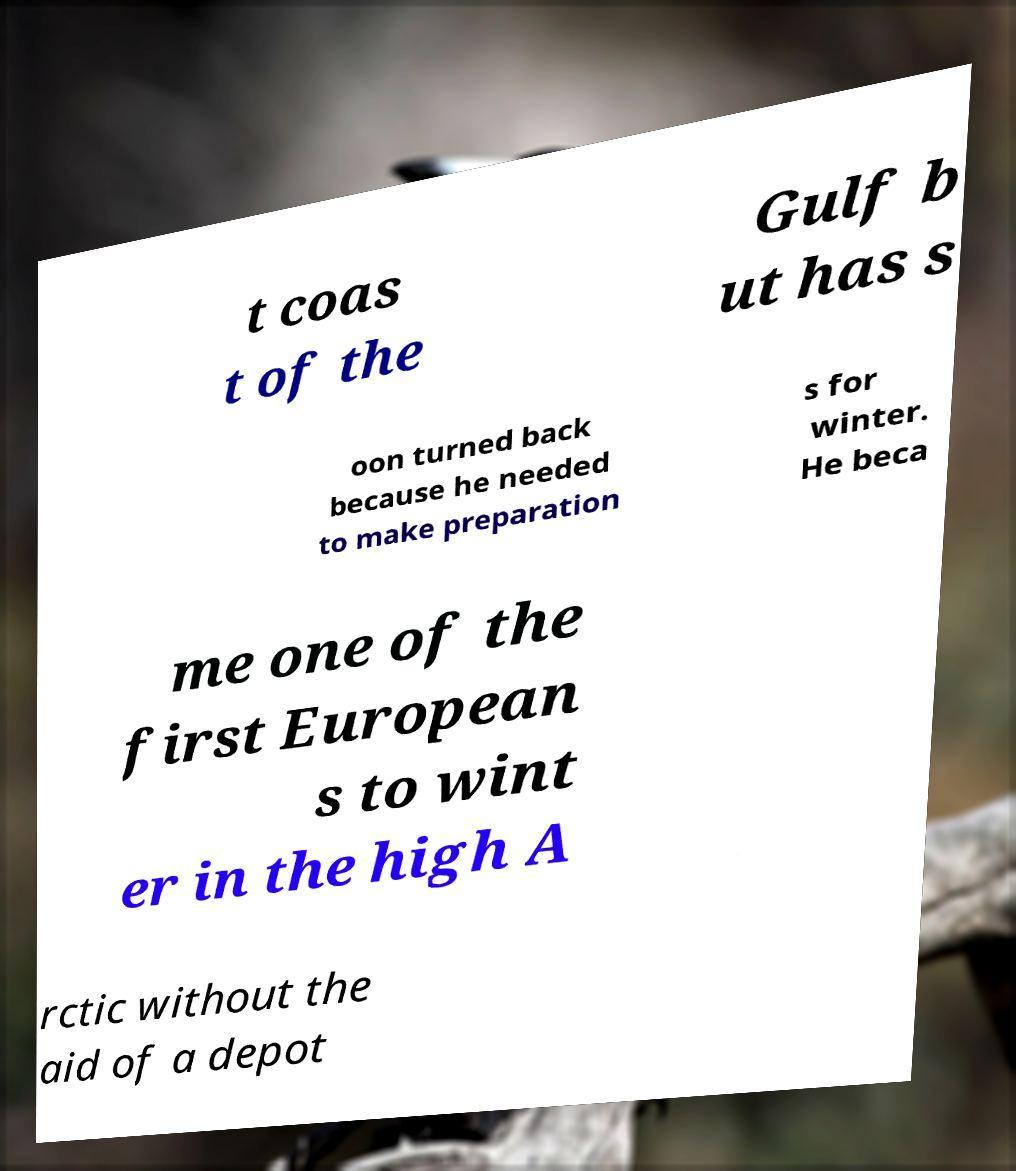Could you extract and type out the text from this image? t coas t of the Gulf b ut has s oon turned back because he needed to make preparation s for winter. He beca me one of the first European s to wint er in the high A rctic without the aid of a depot 